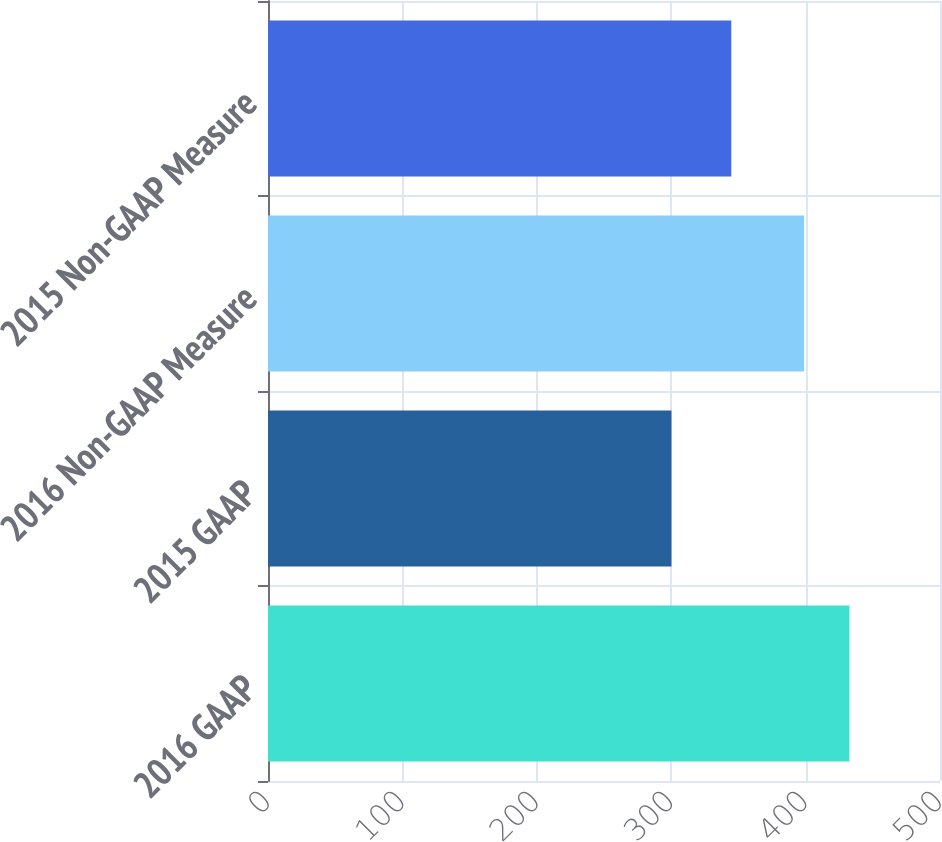Convert chart. <chart><loc_0><loc_0><loc_500><loc_500><bar_chart><fcel>2016 GAAP<fcel>2015 GAAP<fcel>2016 Non-GAAP Measure<fcel>2015 Non-GAAP Measure<nl><fcel>432.6<fcel>300.2<fcel>398.9<fcel>344.7<nl></chart> 